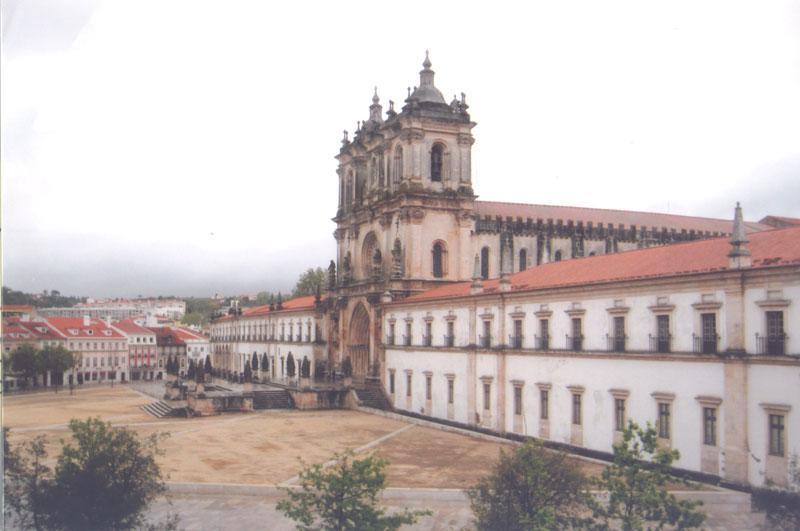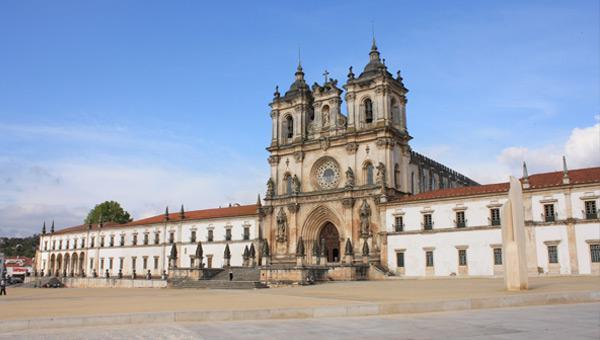The first image is the image on the left, the second image is the image on the right. Examine the images to the left and right. Is the description "Each image has people on the steps in front of the building." accurate? Answer yes or no. No. 